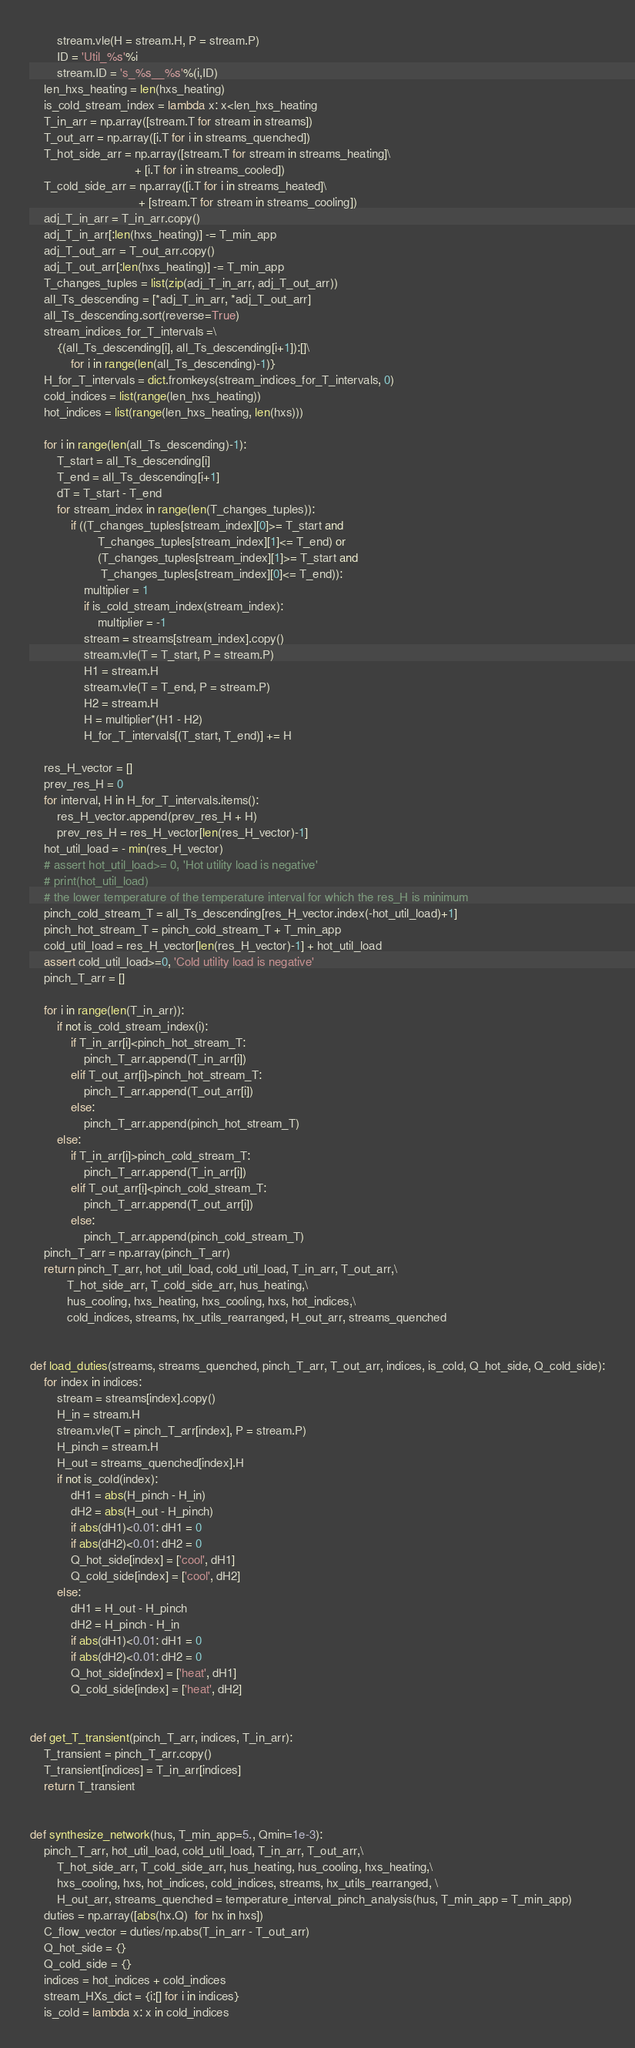<code> <loc_0><loc_0><loc_500><loc_500><_Python_>        stream.vle(H = stream.H, P = stream.P)
        ID = 'Util_%s'%i
        stream.ID = 's_%s__%s'%(i,ID)
    len_hxs_heating = len(hxs_heating)
    is_cold_stream_index = lambda x: x<len_hxs_heating
    T_in_arr = np.array([stream.T for stream in streams])
    T_out_arr = np.array([i.T for i in streams_quenched])
    T_hot_side_arr = np.array([stream.T for stream in streams_heating]\
                               + [i.T for i in streams_cooled])
    T_cold_side_arr = np.array([i.T for i in streams_heated]\
                                + [stream.T for stream in streams_cooling])
    adj_T_in_arr = T_in_arr.copy()
    adj_T_in_arr[:len(hxs_heating)] -= T_min_app
    adj_T_out_arr = T_out_arr.copy()
    adj_T_out_arr[:len(hxs_heating)] -= T_min_app
    T_changes_tuples = list(zip(adj_T_in_arr, adj_T_out_arr))
    all_Ts_descending = [*adj_T_in_arr, *adj_T_out_arr]
    all_Ts_descending.sort(reverse=True)
    stream_indices_for_T_intervals =\
        {(all_Ts_descending[i], all_Ts_descending[i+1]):[]\
            for i in range(len(all_Ts_descending)-1)}
    H_for_T_intervals = dict.fromkeys(stream_indices_for_T_intervals, 0)
    cold_indices = list(range(len_hxs_heating))
    hot_indices = list(range(len_hxs_heating, len(hxs)))
    
    for i in range(len(all_Ts_descending)-1):
        T_start = all_Ts_descending[i]
        T_end = all_Ts_descending[i+1]
        dT = T_start - T_end
        for stream_index in range(len(T_changes_tuples)):
            if ((T_changes_tuples[stream_index][0]>= T_start and
                    T_changes_tuples[stream_index][1]<= T_end) or
                    (T_changes_tuples[stream_index][1]>= T_start and
                     T_changes_tuples[stream_index][0]<= T_end)):
                multiplier = 1
                if is_cold_stream_index(stream_index):
                    multiplier = -1
                stream = streams[stream_index].copy()
                stream.vle(T = T_start, P = stream.P)
                H1 = stream.H
                stream.vle(T = T_end, P = stream.P)
                H2 = stream.H
                H = multiplier*(H1 - H2)
                H_for_T_intervals[(T_start, T_end)] += H
                
    res_H_vector = []
    prev_res_H = 0
    for interval, H in H_for_T_intervals.items():
        res_H_vector.append(prev_res_H + H)
        prev_res_H = res_H_vector[len(res_H_vector)-1]
    hot_util_load = - min(res_H_vector)
    # assert hot_util_load>= 0, 'Hot utility load is negative'
    # print(hot_util_load)
    # the lower temperature of the temperature interval for which the res_H is minimum
    pinch_cold_stream_T = all_Ts_descending[res_H_vector.index(-hot_util_load)+1]
    pinch_hot_stream_T = pinch_cold_stream_T + T_min_app
    cold_util_load = res_H_vector[len(res_H_vector)-1] + hot_util_load
    assert cold_util_load>=0, 'Cold utility load is negative'
    pinch_T_arr = []
    
    for i in range(len(T_in_arr)):
        if not is_cold_stream_index(i):
            if T_in_arr[i]<pinch_hot_stream_T:
                pinch_T_arr.append(T_in_arr[i])
            elif T_out_arr[i]>pinch_hot_stream_T:
                pinch_T_arr.append(T_out_arr[i])
            else:
                pinch_T_arr.append(pinch_hot_stream_T)
        else:
            if T_in_arr[i]>pinch_cold_stream_T:
                pinch_T_arr.append(T_in_arr[i])
            elif T_out_arr[i]<pinch_cold_stream_T:
                pinch_T_arr.append(T_out_arr[i])
            else:
                pinch_T_arr.append(pinch_cold_stream_T)
    pinch_T_arr = np.array(pinch_T_arr)
    return pinch_T_arr, hot_util_load, cold_util_load, T_in_arr, T_out_arr,\
           T_hot_side_arr, T_cold_side_arr, hus_heating,\
           hus_cooling, hxs_heating, hxs_cooling, hxs, hot_indices,\
           cold_indices, streams, hx_utils_rearranged, H_out_arr, streams_quenched
            
        
def load_duties(streams, streams_quenched, pinch_T_arr, T_out_arr, indices, is_cold, Q_hot_side, Q_cold_side):
    for index in indices:
        stream = streams[index].copy()
        H_in = stream.H
        stream.vle(T = pinch_T_arr[index], P = stream.P)
        H_pinch = stream.H
        H_out = streams_quenched[index].H
        if not is_cold(index):
            dH1 = abs(H_pinch - H_in)
            dH2 = abs(H_out - H_pinch)
            if abs(dH1)<0.01: dH1 = 0
            if abs(dH2)<0.01: dH2 = 0
            Q_hot_side[index] = ['cool', dH1]
            Q_cold_side[index] = ['cool', dH2]
        else:
            dH1 = H_out - H_pinch
            dH2 = H_pinch - H_in
            if abs(dH1)<0.01: dH1 = 0
            if abs(dH2)<0.01: dH2 = 0
            Q_hot_side[index] = ['heat', dH1]
            Q_cold_side[index] = ['heat', dH2]
            
            
def get_T_transient(pinch_T_arr, indices, T_in_arr):
    T_transient = pinch_T_arr.copy()
    T_transient[indices] = T_in_arr[indices]
    return T_transient


def synthesize_network(hus, T_min_app=5., Qmin=1e-3):  
    pinch_T_arr, hot_util_load, cold_util_load, T_in_arr, T_out_arr,\
        T_hot_side_arr, T_cold_side_arr, hus_heating, hus_cooling, hxs_heating,\
        hxs_cooling, hxs, hot_indices, cold_indices, streams, hx_utils_rearranged, \
        H_out_arr, streams_quenched = temperature_interval_pinch_analysis(hus, T_min_app = T_min_app)        
    duties = np.array([abs(hx.Q)  for hx in hxs])
    C_flow_vector = duties/np.abs(T_in_arr - T_out_arr)
    Q_hot_side = {}
    Q_cold_side = {}
    indices = hot_indices + cold_indices
    stream_HXs_dict = {i:[] for i in indices}
    is_cold = lambda x: x in cold_indices</code> 